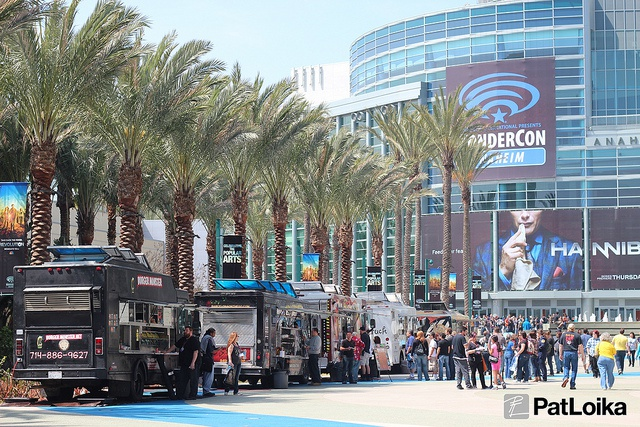Describe the objects in this image and their specific colors. I can see truck in darkgray, black, and gray tones, people in darkgray, black, gray, and lightgray tones, truck in darkgray, black, and gray tones, truck in darkgray, lightgray, and gray tones, and people in darkgray, black, brown, and maroon tones in this image. 